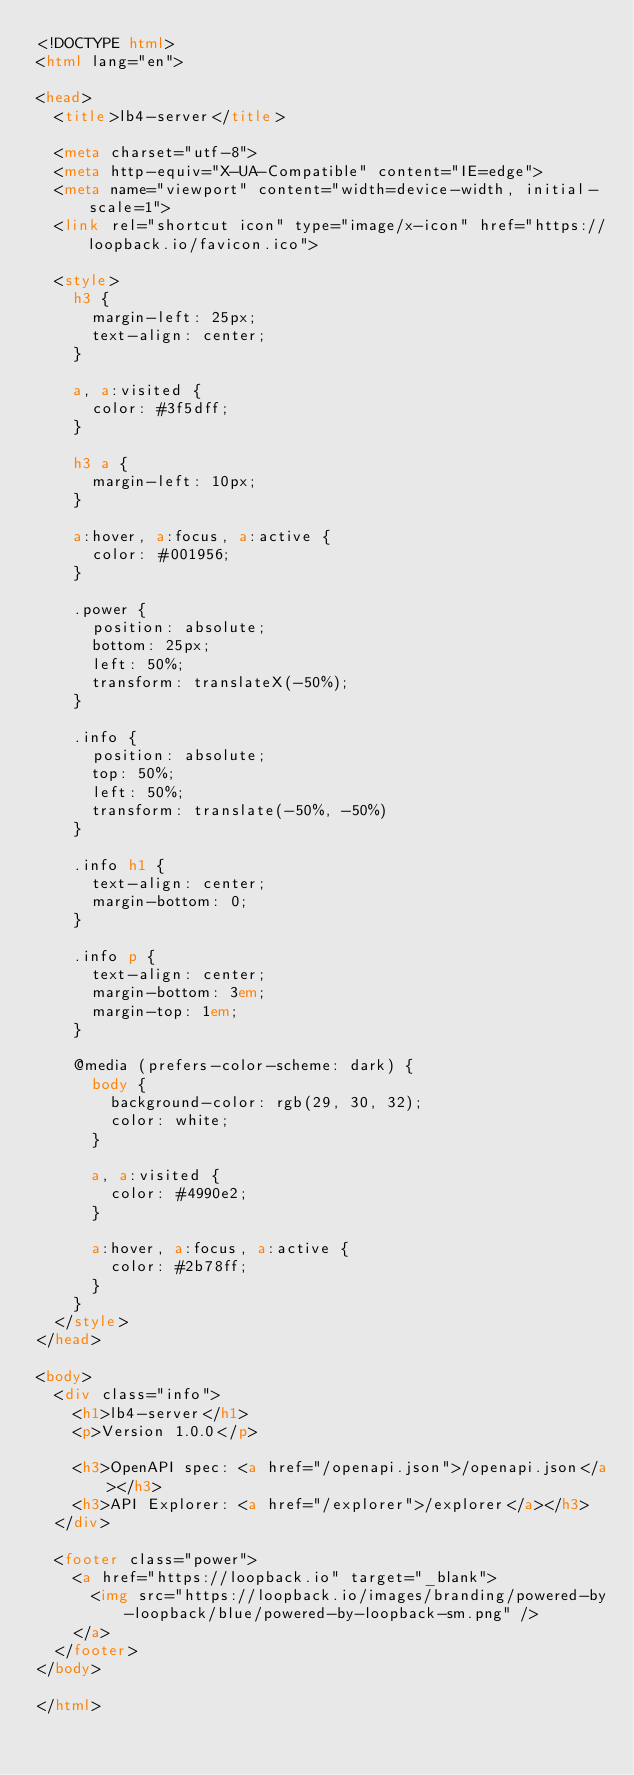Convert code to text. <code><loc_0><loc_0><loc_500><loc_500><_HTML_><!DOCTYPE html>
<html lang="en">

<head>
  <title>lb4-server</title>

  <meta charset="utf-8">
  <meta http-equiv="X-UA-Compatible" content="IE=edge">
  <meta name="viewport" content="width=device-width, initial-scale=1">
  <link rel="shortcut icon" type="image/x-icon" href="https://loopback.io/favicon.ico">

  <style>
    h3 {
      margin-left: 25px;
      text-align: center;
    }

    a, a:visited {
      color: #3f5dff;
    }

    h3 a {
      margin-left: 10px;
    }

    a:hover, a:focus, a:active {
      color: #001956;
    }

    .power {
      position: absolute;
      bottom: 25px;
      left: 50%;
      transform: translateX(-50%);
    }

    .info {
      position: absolute;
      top: 50%;
      left: 50%;
      transform: translate(-50%, -50%)
    }

    .info h1 {
      text-align: center;
      margin-bottom: 0;
    }

    .info p {
      text-align: center;
      margin-bottom: 3em;
      margin-top: 1em;
    }

    @media (prefers-color-scheme: dark) {
      body {
        background-color: rgb(29, 30, 32);
        color: white;
      }

      a, a:visited {
        color: #4990e2;
      }

      a:hover, a:focus, a:active {
        color: #2b78ff;
      }
    }
  </style>
</head>

<body>
  <div class="info">
    <h1>lb4-server</h1>
    <p>Version 1.0.0</p>

    <h3>OpenAPI spec: <a href="/openapi.json">/openapi.json</a></h3>
    <h3>API Explorer: <a href="/explorer">/explorer</a></h3>
  </div>

  <footer class="power">
    <a href="https://loopback.io" target="_blank">
      <img src="https://loopback.io/images/branding/powered-by-loopback/blue/powered-by-loopback-sm.png" />
    </a>
  </footer>
</body>

</html>
</code> 